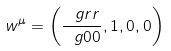Convert formula to latex. <formula><loc_0><loc_0><loc_500><loc_500>w ^ { \mu } = \left ( \frac { \ g r r } { \ g 0 0 } , 1 , 0 , 0 \right )</formula> 